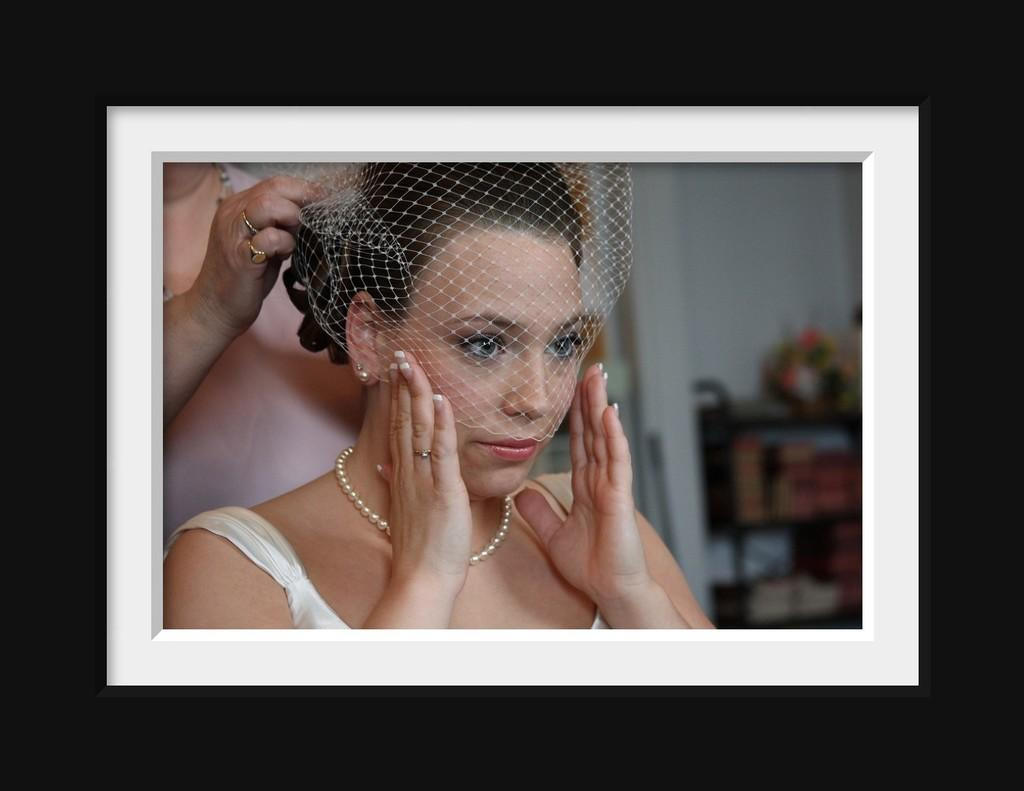What type of object is the image depicting? The image is a photo frame. Can you describe the background of the photo? The background of the photo is dark. How many people are in the photo? There are two persons in the photo. What can be seen behind the people in the photo? There is a wall visible in the photo. How is the background of the photo depicted? The background of the photo is blurry. What else is visible in the photo besides the people and the wall? Objects are present on racks in the photo. What type of car is parked in front of the wall in the photo? There is no car present in the photo; it only shows two persons, a wall, and objects on racks. Can you tell me how many calculators are visible on the racks in the photo? There is no calculator visible on the racks in the photo; only objects are present. 